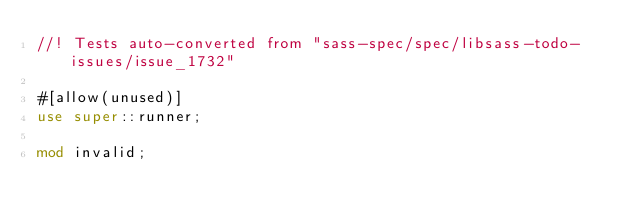<code> <loc_0><loc_0><loc_500><loc_500><_Rust_>//! Tests auto-converted from "sass-spec/spec/libsass-todo-issues/issue_1732"

#[allow(unused)]
use super::runner;

mod invalid;
</code> 